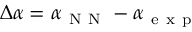<formula> <loc_0><loc_0><loc_500><loc_500>\Delta \alpha = \alpha _ { N N } - \alpha _ { e x p }</formula> 